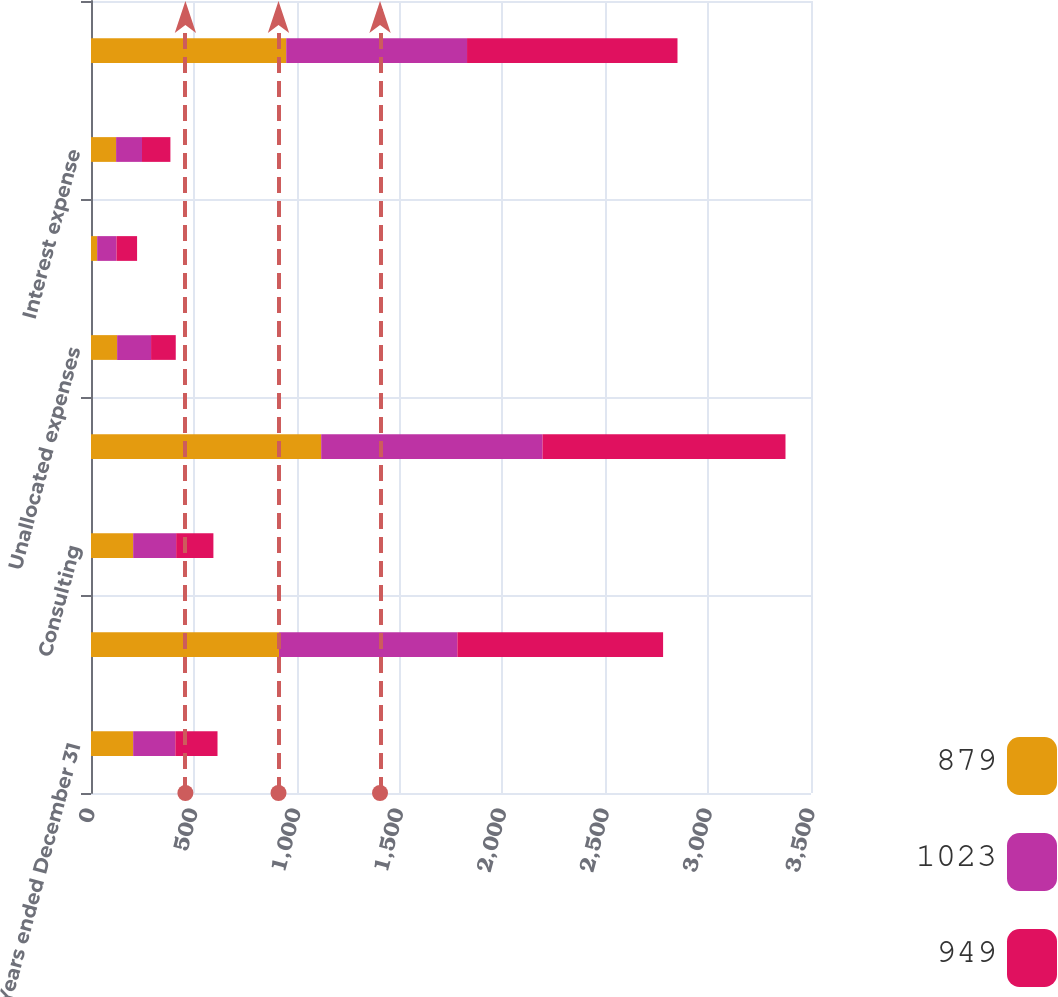Convert chart to OTSL. <chart><loc_0><loc_0><loc_500><loc_500><stacked_bar_chart><ecel><fcel>Years ended December 31<fcel>Risk and Insurance Brokerage<fcel>Consulting<fcel>Segment income from continuing<fcel>Unallocated expenses<fcel>Interest income<fcel>Interest expense<fcel>Income from continuing<nl><fcel>879<fcel>205<fcel>914<fcel>205<fcel>1119<fcel>127<fcel>30<fcel>122<fcel>949<nl><fcel>1023<fcel>205<fcel>867<fcel>209<fcel>1076<fcel>165<fcel>94<fcel>126<fcel>879<nl><fcel>949<fcel>205<fcel>1000<fcel>181<fcel>1181<fcel>120<fcel>100<fcel>138<fcel>1023<nl></chart> 